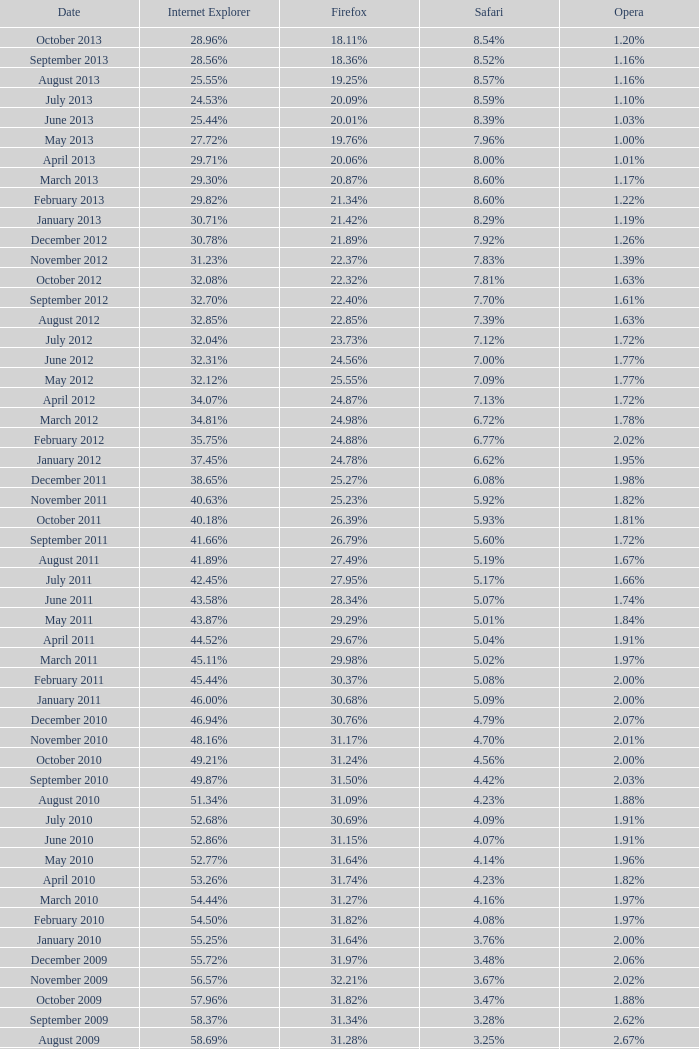What proportion of browsers utilized internet explorer during the time when 2 64.43%. 